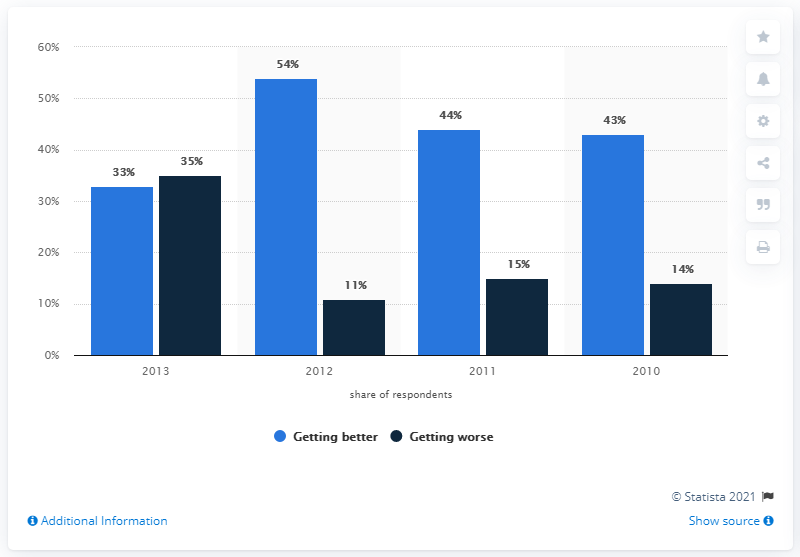Outline some significant characteristics in this image. The difference between the highest and the lowest dark blue bar is 24. The standard of living in the country with the highest standard of living is either getting better or getting worse. 